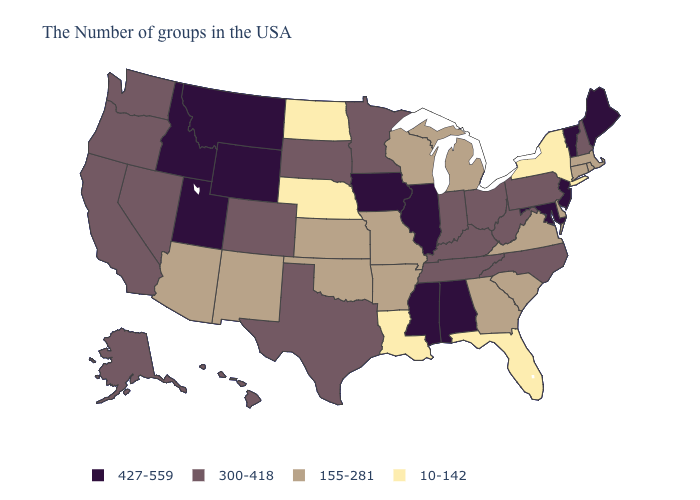Name the states that have a value in the range 300-418?
Write a very short answer. New Hampshire, Pennsylvania, North Carolina, West Virginia, Ohio, Kentucky, Indiana, Tennessee, Minnesota, Texas, South Dakota, Colorado, Nevada, California, Washington, Oregon, Alaska, Hawaii. Which states hav the highest value in the MidWest?
Write a very short answer. Illinois, Iowa. What is the highest value in the MidWest ?
Quick response, please. 427-559. Does Pennsylvania have a higher value than Georgia?
Short answer required. Yes. Name the states that have a value in the range 155-281?
Short answer required. Massachusetts, Rhode Island, Connecticut, Delaware, Virginia, South Carolina, Georgia, Michigan, Wisconsin, Missouri, Arkansas, Kansas, Oklahoma, New Mexico, Arizona. What is the highest value in the USA?
Write a very short answer. 427-559. Does Tennessee have the lowest value in the South?
Write a very short answer. No. Name the states that have a value in the range 300-418?
Give a very brief answer. New Hampshire, Pennsylvania, North Carolina, West Virginia, Ohio, Kentucky, Indiana, Tennessee, Minnesota, Texas, South Dakota, Colorado, Nevada, California, Washington, Oregon, Alaska, Hawaii. Does the map have missing data?
Be succinct. No. Name the states that have a value in the range 10-142?
Short answer required. New York, Florida, Louisiana, Nebraska, North Dakota. Name the states that have a value in the range 300-418?
Concise answer only. New Hampshire, Pennsylvania, North Carolina, West Virginia, Ohio, Kentucky, Indiana, Tennessee, Minnesota, Texas, South Dakota, Colorado, Nevada, California, Washington, Oregon, Alaska, Hawaii. Name the states that have a value in the range 155-281?
Short answer required. Massachusetts, Rhode Island, Connecticut, Delaware, Virginia, South Carolina, Georgia, Michigan, Wisconsin, Missouri, Arkansas, Kansas, Oklahoma, New Mexico, Arizona. Among the states that border Georgia , does Florida have the lowest value?
Short answer required. Yes. What is the value of Mississippi?
Short answer required. 427-559. Does California have the highest value in the West?
Give a very brief answer. No. 